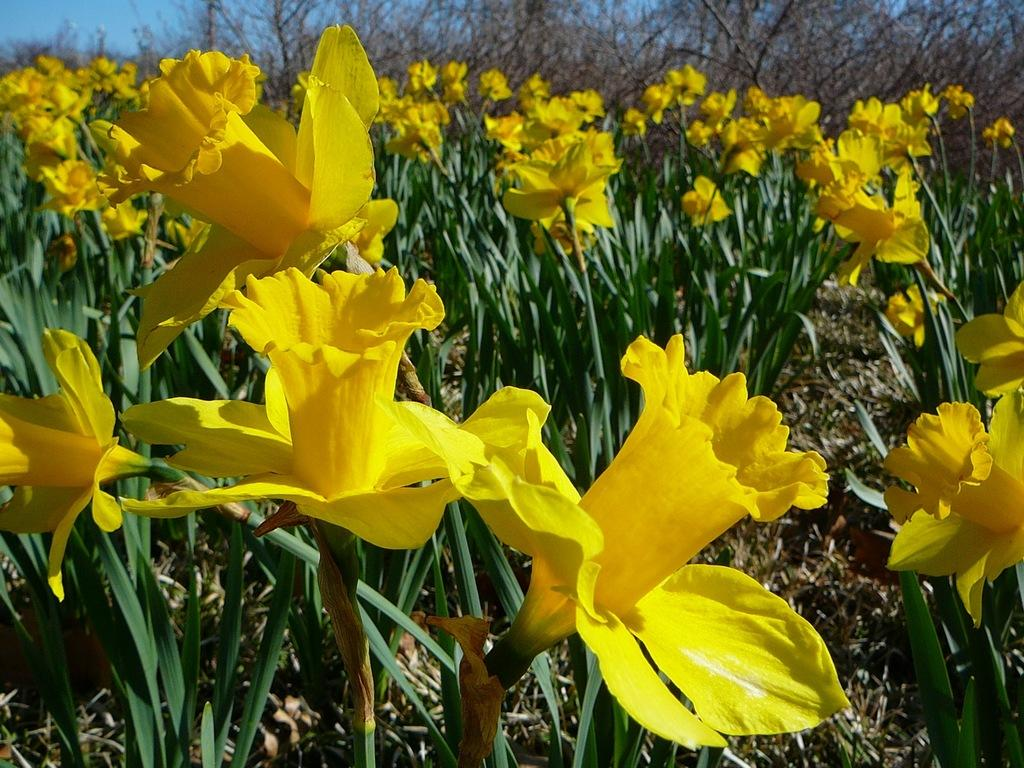What type of vegetation can be seen in the image? There are flowers, plants, and trees in the image. What part of the natural environment is visible in the image? The sky is visible in the image. What type of church can be seen in the image? There is no church present in the image; it features flowers, plants, trees, and the sky. 